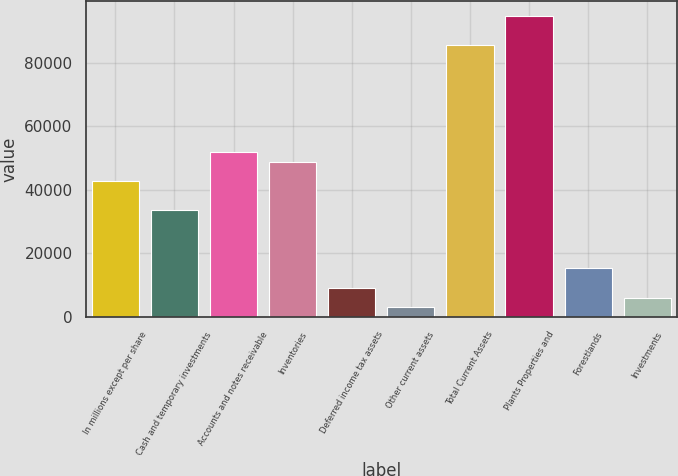Convert chart. <chart><loc_0><loc_0><loc_500><loc_500><bar_chart><fcel>In millions except per share<fcel>Cash and temporary investments<fcel>Accounts and notes receivable<fcel>Inventories<fcel>Deferred income tax assets<fcel>Other current assets<fcel>Total Current Assets<fcel>Plants Properties and<fcel>Forestlands<fcel>Investments<nl><fcel>42733.4<fcel>33581.6<fcel>51885.2<fcel>48834.6<fcel>9176.8<fcel>3075.6<fcel>85441.8<fcel>94593.6<fcel>15278<fcel>6126.2<nl></chart> 